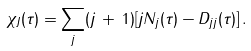Convert formula to latex. <formula><loc_0><loc_0><loc_500><loc_500>\chi _ { J } ( \tau ) = \sum _ { j } ( j \, + \, 1 ) [ j N _ { j } ( \tau ) - D _ { j j } ( \tau ) ] \, .</formula> 